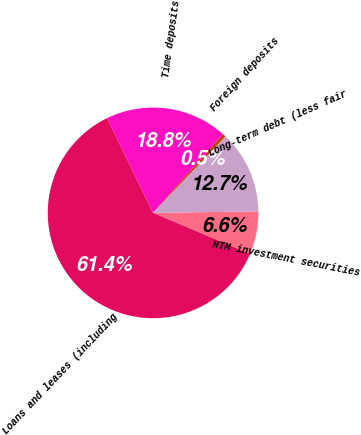<chart> <loc_0><loc_0><loc_500><loc_500><pie_chart><fcel>HTM investment securities<fcel>Loans and leases (including<fcel>Time deposits<fcel>Foreign deposits<fcel>Long-term debt (less fair<nl><fcel>6.6%<fcel>61.42%<fcel>18.78%<fcel>0.51%<fcel>12.69%<nl></chart> 